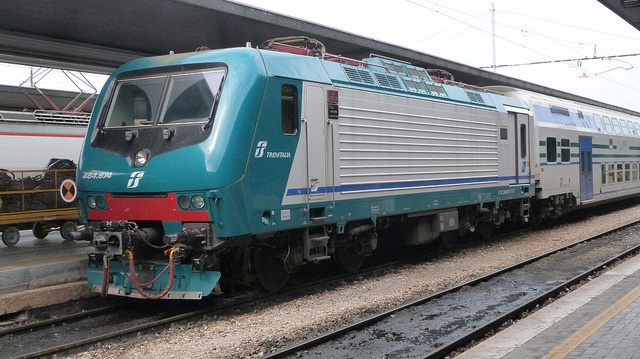Describe the objects in this image and their specific colors. I can see train in black, darkgray, teal, and gray tones and train in black, darkgray, lightgray, and gray tones in this image. 